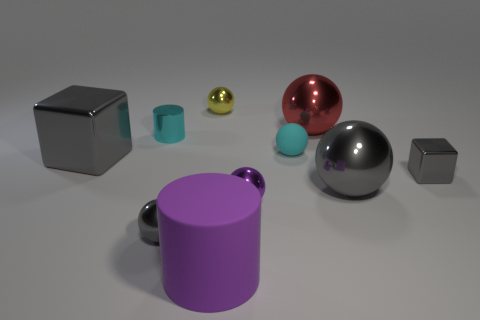Subtract all red metallic balls. How many balls are left? 5 Subtract all red cubes. How many gray spheres are left? 2 Subtract 2 spheres. How many spheres are left? 4 Subtract all red balls. How many balls are left? 5 Subtract all brown balls. Subtract all yellow cubes. How many balls are left? 6 Subtract 0 red cylinders. How many objects are left? 10 Subtract all cylinders. How many objects are left? 8 Subtract all large purple things. Subtract all small cyan shiny objects. How many objects are left? 8 Add 2 purple cylinders. How many purple cylinders are left? 3 Add 2 small green blocks. How many small green blocks exist? 2 